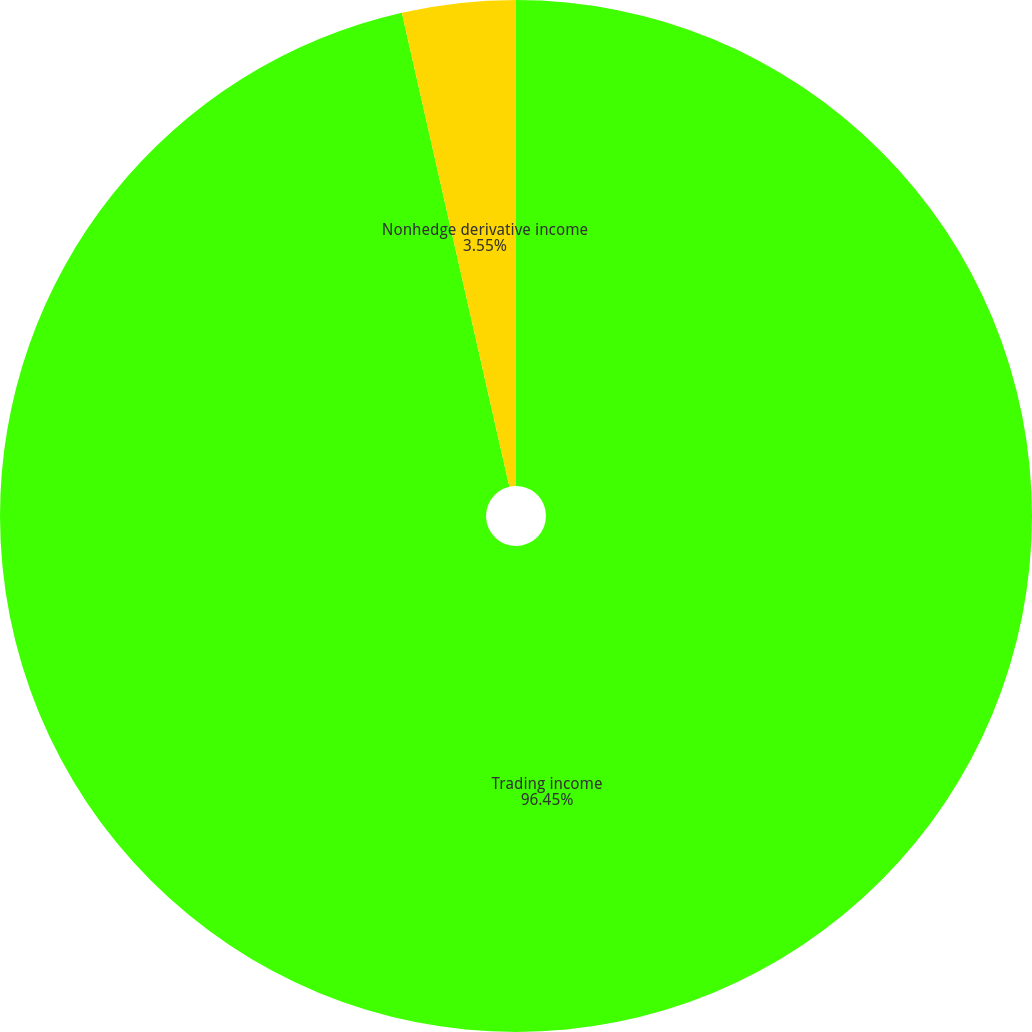Convert chart to OTSL. <chart><loc_0><loc_0><loc_500><loc_500><pie_chart><fcel>Trading income<fcel>Nonhedge derivative income<nl><fcel>96.45%<fcel>3.55%<nl></chart> 